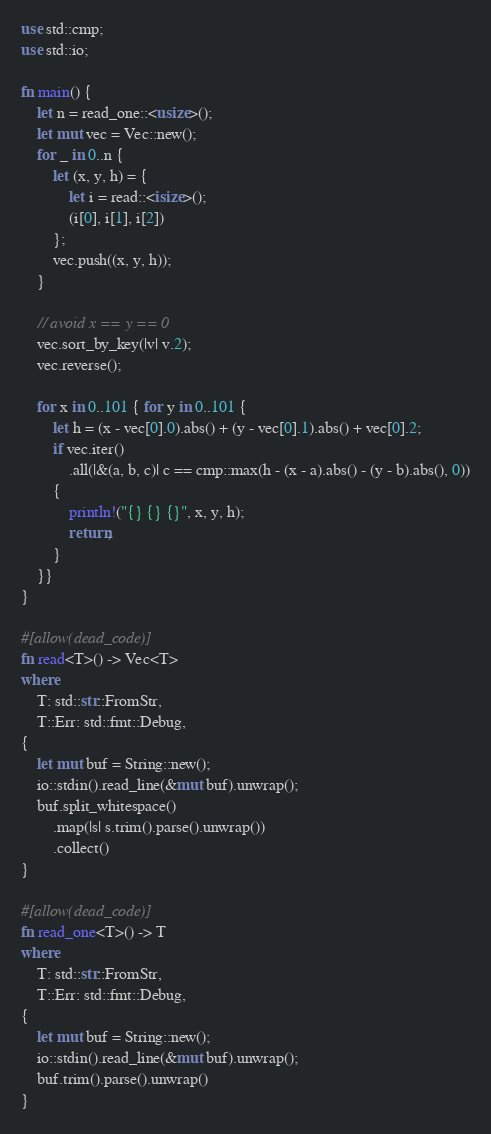Convert code to text. <code><loc_0><loc_0><loc_500><loc_500><_Rust_>use std::cmp;
use std::io;

fn main() {
    let n = read_one::<usize>();
    let mut vec = Vec::new();
    for _ in 0..n {
        let (x, y, h) = {
            let i = read::<isize>();
            (i[0], i[1], i[2])
        };
        vec.push((x, y, h));
    }

    // avoid x == y == 0
    vec.sort_by_key(|v| v.2);
    vec.reverse();

    for x in 0..101 { for y in 0..101 {
        let h = (x - vec[0].0).abs() + (y - vec[0].1).abs() + vec[0].2;
        if vec.iter()
            .all(|&(a, b, c)| c == cmp::max(h - (x - a).abs() - (y - b).abs(), 0))
        {
            println!("{} {} {}", x, y, h);
            return;
        }
    }}
}

#[allow(dead_code)]
fn read<T>() -> Vec<T>
where
    T: std::str::FromStr,
    T::Err: std::fmt::Debug,
{
    let mut buf = String::new();
    io::stdin().read_line(&mut buf).unwrap();
    buf.split_whitespace()
        .map(|s| s.trim().parse().unwrap())
        .collect()
}

#[allow(dead_code)]
fn read_one<T>() -> T
where
    T: std::str::FromStr,
    T::Err: std::fmt::Debug,
{
    let mut buf = String::new();
    io::stdin().read_line(&mut buf).unwrap();
    buf.trim().parse().unwrap()
}</code> 